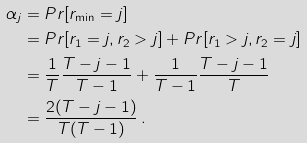<formula> <loc_0><loc_0><loc_500><loc_500>\alpha _ { j } & = P r [ r _ { \min } = j ] \\ & = P r [ r _ { 1 } = j , r _ { 2 } > j ] + P r [ r _ { 1 } > j , r _ { 2 } = j ] \\ & = \frac { 1 } { T } \frac { T - j - 1 } { T - 1 } + \frac { 1 } { T - 1 } \frac { T - j - 1 } { T } \\ & = \frac { 2 ( T - j - 1 ) } { T ( T - 1 ) } \, .</formula> 